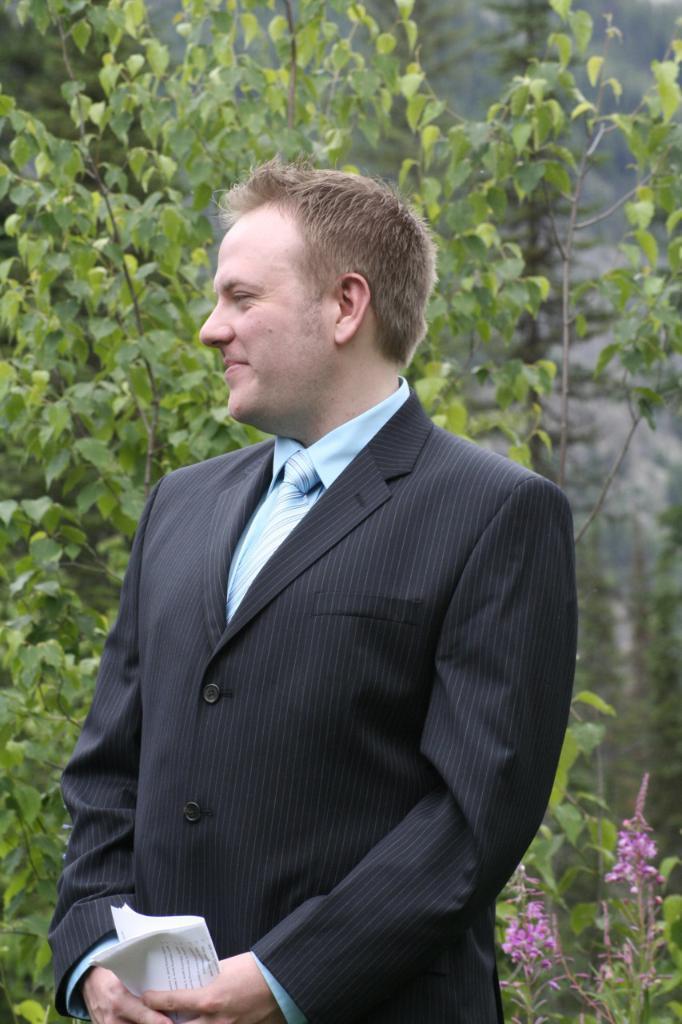Describe this image in one or two sentences. In this image I can see a person wearing black color coat and blue tie. Person is holding papers. Back Side I can see trees and pink color flowers. 